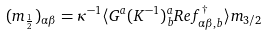<formula> <loc_0><loc_0><loc_500><loc_500>( m _ { \frac { 1 } { 2 } } ) _ { \alpha \beta } = \kappa ^ { - 1 } \langle G ^ { a } ( K ^ { - 1 } ) ^ { a } _ { b } R e f _ { \alpha \beta , b } ^ { \dag } \rangle m _ { 3 / 2 }</formula> 